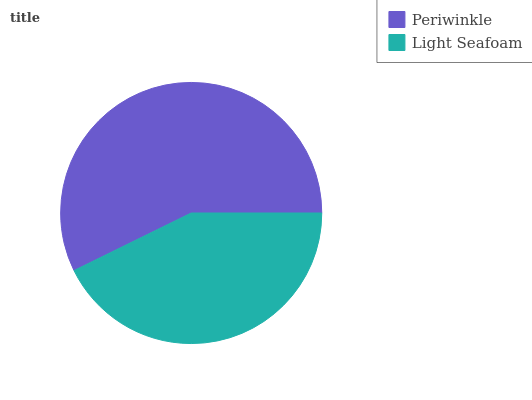Is Light Seafoam the minimum?
Answer yes or no. Yes. Is Periwinkle the maximum?
Answer yes or no. Yes. Is Light Seafoam the maximum?
Answer yes or no. No. Is Periwinkle greater than Light Seafoam?
Answer yes or no. Yes. Is Light Seafoam less than Periwinkle?
Answer yes or no. Yes. Is Light Seafoam greater than Periwinkle?
Answer yes or no. No. Is Periwinkle less than Light Seafoam?
Answer yes or no. No. Is Periwinkle the high median?
Answer yes or no. Yes. Is Light Seafoam the low median?
Answer yes or no. Yes. Is Light Seafoam the high median?
Answer yes or no. No. Is Periwinkle the low median?
Answer yes or no. No. 